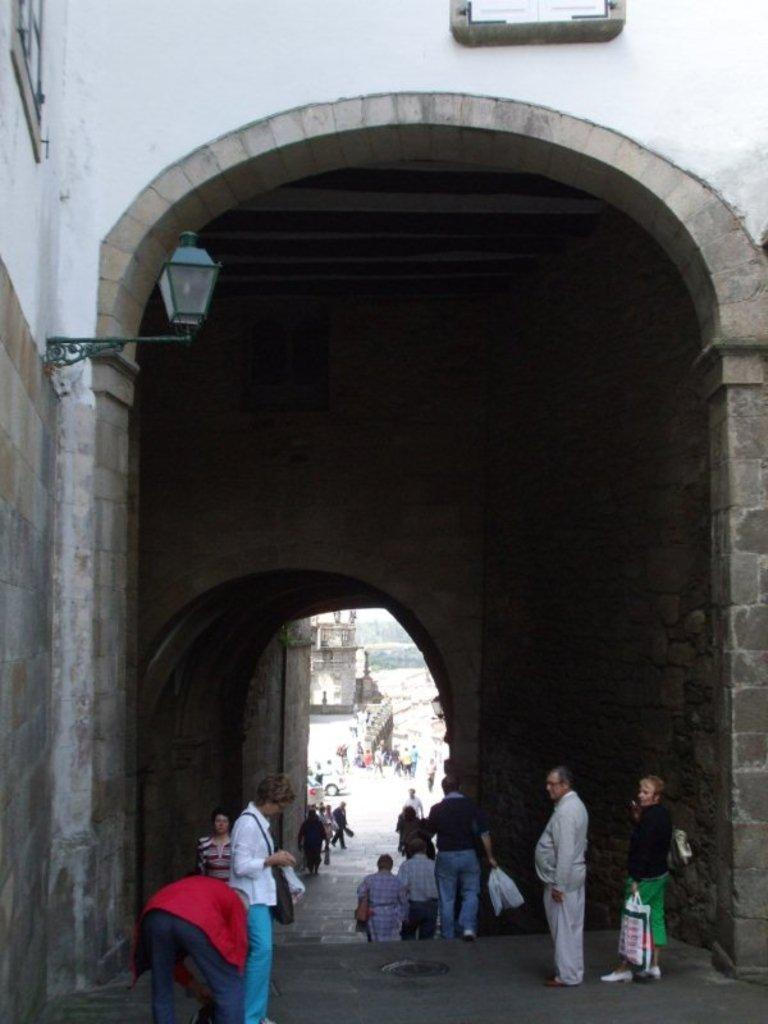What is the main structure visible in the image? There is a tunnel in the image. What can be seen near the tunnel? There are people under the tunnel. Is there any lighting source visible in the image? Yes, there is a lamp on the left side of the image, attached to a wall. What type of bag is being used for the treatment of hair in the image? There is no bag or hair treatment present in the image; it only features a tunnel, people, and a lamp. 